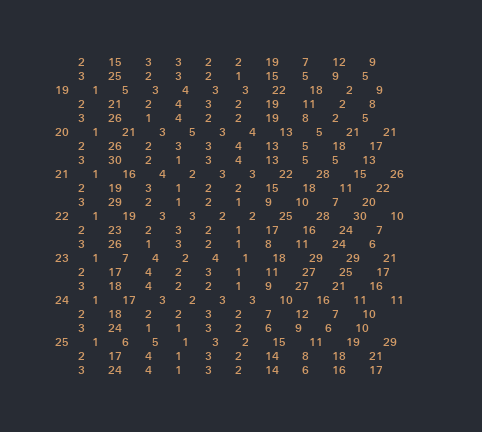<code> <loc_0><loc_0><loc_500><loc_500><_ObjectiveC_>	2	15	3	3	2	2	19	7	12	9	
	3	25	2	3	2	1	15	5	9	5	
19	1	5	3	4	3	3	22	18	2	9	
	2	21	2	4	3	2	19	11	2	8	
	3	26	1	4	2	2	19	8	2	5	
20	1	21	3	5	3	4	13	5	21	21	
	2	26	2	3	3	4	13	5	18	17	
	3	30	2	1	3	4	13	5	5	13	
21	1	16	4	2	3	3	22	28	15	26	
	2	19	3	1	2	2	15	18	11	22	
	3	29	2	1	2	1	9	10	7	20	
22	1	19	3	3	2	2	25	28	30	10	
	2	23	2	3	2	1	17	16	24	7	
	3	26	1	3	2	1	8	11	24	6	
23	1	7	4	2	4	1	18	29	29	21	
	2	17	4	2	3	1	11	27	25	17	
	3	18	4	2	2	1	9	27	21	16	
24	1	17	3	2	3	3	10	16	11	11	
	2	18	2	2	3	2	7	12	7	10	
	3	24	1	1	3	2	6	9	6	10	
25	1	6	5	1	3	2	15	11	19	29	
	2	17	4	1	3	2	14	8	18	21	
	3	24	4	1	3	2	14	6	16	17	</code> 